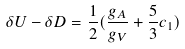Convert formula to latex. <formula><loc_0><loc_0><loc_500><loc_500>\delta U - \delta D = \frac { 1 } { 2 } ( \frac { g _ { A } } { g _ { V } } + \frac { 5 } { 3 } c _ { 1 } )</formula> 